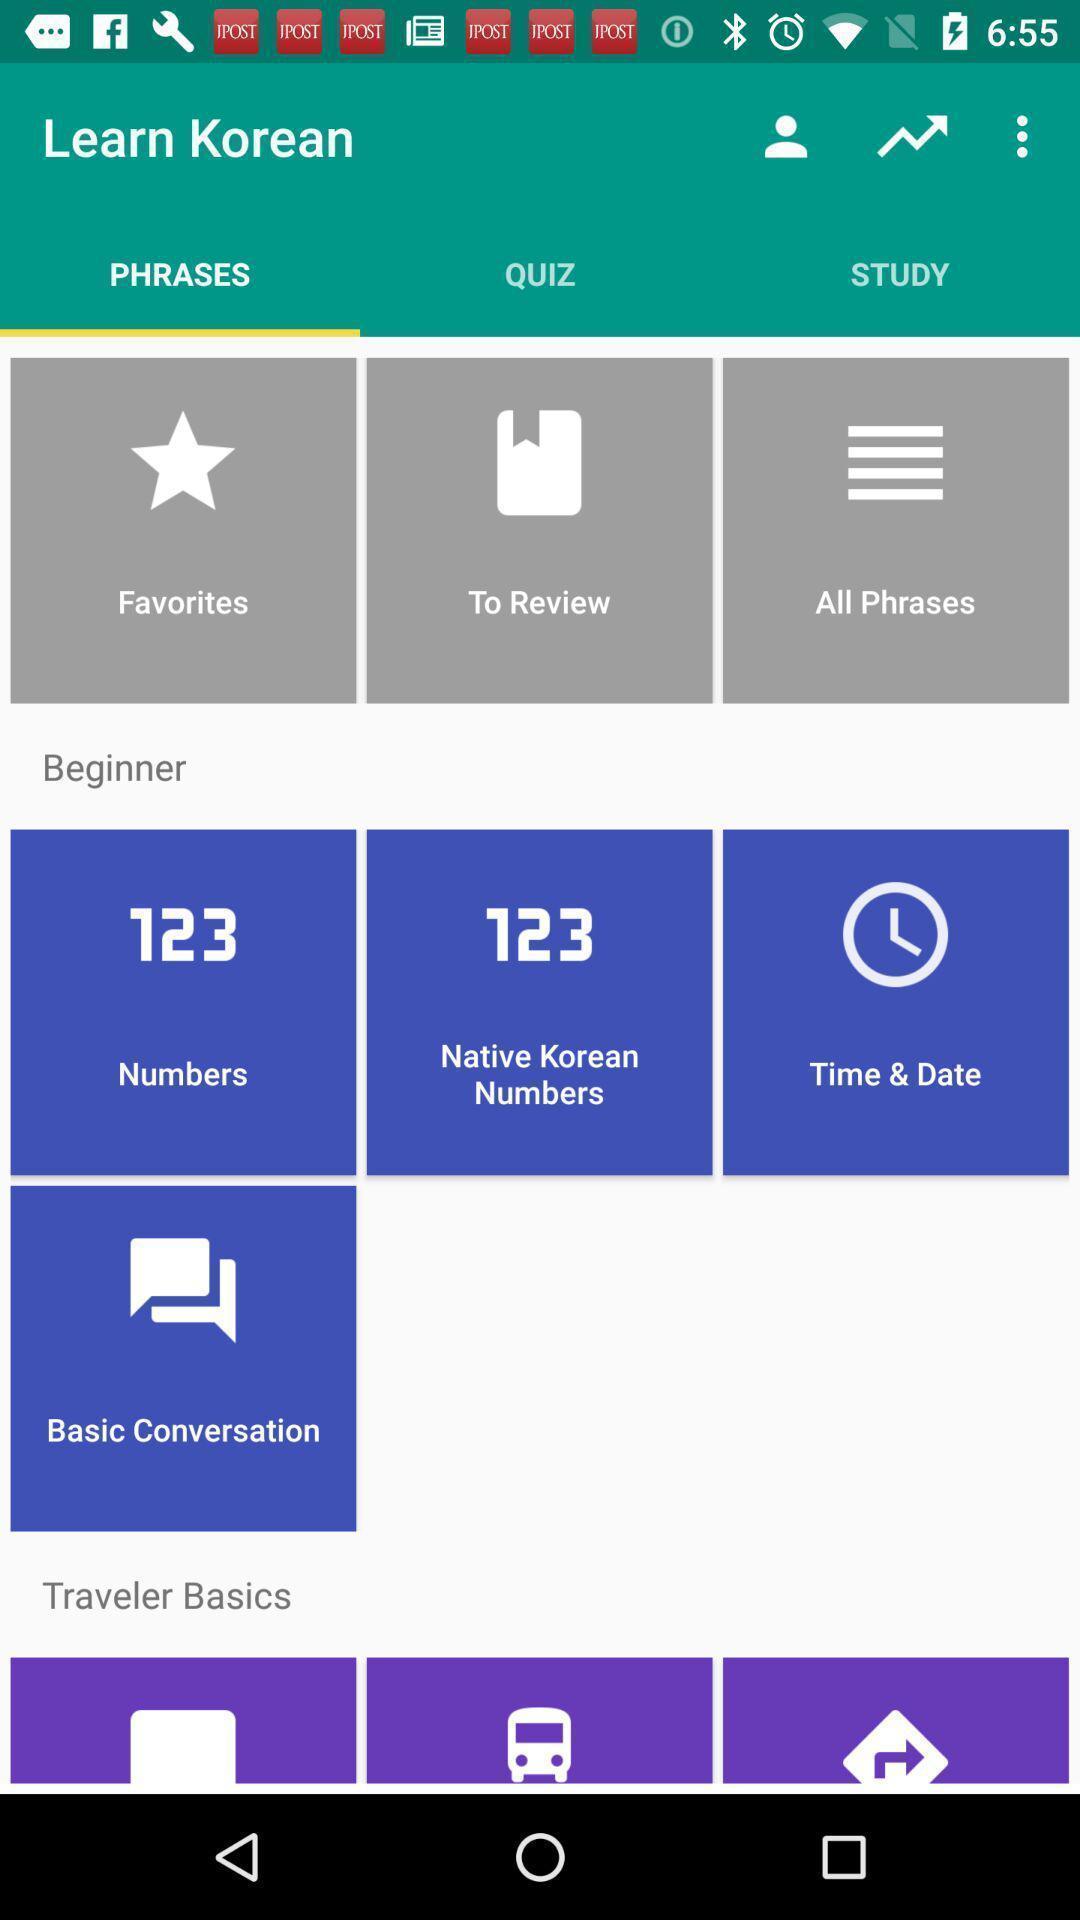Describe the visual elements of this screenshot. Phrases page based on different categories. 